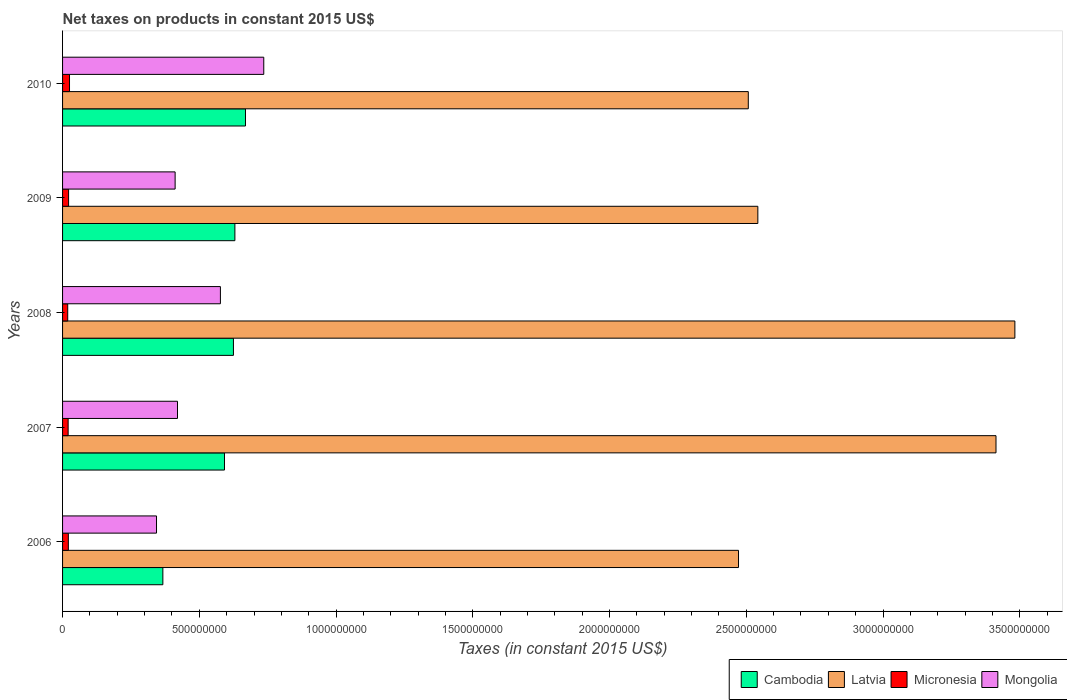How many groups of bars are there?
Make the answer very short. 5. Are the number of bars per tick equal to the number of legend labels?
Give a very brief answer. Yes. Are the number of bars on each tick of the Y-axis equal?
Keep it short and to the point. Yes. How many bars are there on the 1st tick from the top?
Your answer should be compact. 4. How many bars are there on the 4th tick from the bottom?
Ensure brevity in your answer.  4. What is the net taxes on products in Cambodia in 2008?
Offer a terse response. 6.25e+08. Across all years, what is the maximum net taxes on products in Latvia?
Provide a short and direct response. 3.48e+09. Across all years, what is the minimum net taxes on products in Mongolia?
Provide a short and direct response. 3.44e+08. In which year was the net taxes on products in Latvia maximum?
Provide a short and direct response. 2008. In which year was the net taxes on products in Mongolia minimum?
Provide a succinct answer. 2006. What is the total net taxes on products in Mongolia in the graph?
Offer a very short reply. 2.49e+09. What is the difference between the net taxes on products in Latvia in 2006 and that in 2007?
Your response must be concise. -9.41e+08. What is the difference between the net taxes on products in Latvia in 2010 and the net taxes on products in Mongolia in 2008?
Your answer should be very brief. 1.93e+09. What is the average net taxes on products in Mongolia per year?
Your answer should be compact. 4.98e+08. In the year 2007, what is the difference between the net taxes on products in Mongolia and net taxes on products in Latvia?
Your answer should be compact. -2.99e+09. In how many years, is the net taxes on products in Latvia greater than 400000000 US$?
Keep it short and to the point. 5. What is the ratio of the net taxes on products in Cambodia in 2006 to that in 2007?
Make the answer very short. 0.62. Is the net taxes on products in Latvia in 2006 less than that in 2009?
Ensure brevity in your answer.  Yes. What is the difference between the highest and the second highest net taxes on products in Latvia?
Give a very brief answer. 6.90e+07. What is the difference between the highest and the lowest net taxes on products in Mongolia?
Provide a short and direct response. 3.92e+08. In how many years, is the net taxes on products in Latvia greater than the average net taxes on products in Latvia taken over all years?
Give a very brief answer. 2. Is it the case that in every year, the sum of the net taxes on products in Mongolia and net taxes on products in Latvia is greater than the sum of net taxes on products in Micronesia and net taxes on products in Cambodia?
Give a very brief answer. No. What does the 3rd bar from the top in 2009 represents?
Your answer should be compact. Latvia. What does the 1st bar from the bottom in 2006 represents?
Give a very brief answer. Cambodia. Is it the case that in every year, the sum of the net taxes on products in Latvia and net taxes on products in Cambodia is greater than the net taxes on products in Micronesia?
Ensure brevity in your answer.  Yes. Are all the bars in the graph horizontal?
Your answer should be compact. Yes. How many years are there in the graph?
Make the answer very short. 5. What is the difference between two consecutive major ticks on the X-axis?
Keep it short and to the point. 5.00e+08. Are the values on the major ticks of X-axis written in scientific E-notation?
Ensure brevity in your answer.  No. Does the graph contain any zero values?
Your answer should be very brief. No. How many legend labels are there?
Offer a very short reply. 4. What is the title of the graph?
Provide a short and direct response. Net taxes on products in constant 2015 US$. What is the label or title of the X-axis?
Your response must be concise. Taxes (in constant 2015 US$). What is the label or title of the Y-axis?
Your response must be concise. Years. What is the Taxes (in constant 2015 US$) of Cambodia in 2006?
Provide a succinct answer. 3.67e+08. What is the Taxes (in constant 2015 US$) in Latvia in 2006?
Provide a succinct answer. 2.47e+09. What is the Taxes (in constant 2015 US$) in Micronesia in 2006?
Ensure brevity in your answer.  2.11e+07. What is the Taxes (in constant 2015 US$) of Mongolia in 2006?
Your response must be concise. 3.44e+08. What is the Taxes (in constant 2015 US$) in Cambodia in 2007?
Provide a short and direct response. 5.92e+08. What is the Taxes (in constant 2015 US$) of Latvia in 2007?
Provide a short and direct response. 3.41e+09. What is the Taxes (in constant 2015 US$) in Micronesia in 2007?
Keep it short and to the point. 2.04e+07. What is the Taxes (in constant 2015 US$) in Mongolia in 2007?
Ensure brevity in your answer.  4.20e+08. What is the Taxes (in constant 2015 US$) in Cambodia in 2008?
Your response must be concise. 6.25e+08. What is the Taxes (in constant 2015 US$) in Latvia in 2008?
Your response must be concise. 3.48e+09. What is the Taxes (in constant 2015 US$) in Micronesia in 2008?
Your response must be concise. 1.88e+07. What is the Taxes (in constant 2015 US$) in Mongolia in 2008?
Give a very brief answer. 5.77e+08. What is the Taxes (in constant 2015 US$) in Cambodia in 2009?
Provide a succinct answer. 6.30e+08. What is the Taxes (in constant 2015 US$) in Latvia in 2009?
Your answer should be very brief. 2.54e+09. What is the Taxes (in constant 2015 US$) of Micronesia in 2009?
Give a very brief answer. 2.20e+07. What is the Taxes (in constant 2015 US$) of Mongolia in 2009?
Your answer should be compact. 4.12e+08. What is the Taxes (in constant 2015 US$) in Cambodia in 2010?
Your response must be concise. 6.69e+08. What is the Taxes (in constant 2015 US$) in Latvia in 2010?
Keep it short and to the point. 2.51e+09. What is the Taxes (in constant 2015 US$) in Micronesia in 2010?
Your answer should be compact. 2.54e+07. What is the Taxes (in constant 2015 US$) in Mongolia in 2010?
Make the answer very short. 7.36e+08. Across all years, what is the maximum Taxes (in constant 2015 US$) of Cambodia?
Your answer should be very brief. 6.69e+08. Across all years, what is the maximum Taxes (in constant 2015 US$) in Latvia?
Provide a short and direct response. 3.48e+09. Across all years, what is the maximum Taxes (in constant 2015 US$) of Micronesia?
Your answer should be very brief. 2.54e+07. Across all years, what is the maximum Taxes (in constant 2015 US$) in Mongolia?
Keep it short and to the point. 7.36e+08. Across all years, what is the minimum Taxes (in constant 2015 US$) of Cambodia?
Keep it short and to the point. 3.67e+08. Across all years, what is the minimum Taxes (in constant 2015 US$) in Latvia?
Your answer should be very brief. 2.47e+09. Across all years, what is the minimum Taxes (in constant 2015 US$) of Micronesia?
Offer a terse response. 1.88e+07. Across all years, what is the minimum Taxes (in constant 2015 US$) of Mongolia?
Provide a succinct answer. 3.44e+08. What is the total Taxes (in constant 2015 US$) of Cambodia in the graph?
Offer a very short reply. 2.88e+09. What is the total Taxes (in constant 2015 US$) of Latvia in the graph?
Your answer should be very brief. 1.44e+1. What is the total Taxes (in constant 2015 US$) in Micronesia in the graph?
Give a very brief answer. 1.08e+08. What is the total Taxes (in constant 2015 US$) of Mongolia in the graph?
Ensure brevity in your answer.  2.49e+09. What is the difference between the Taxes (in constant 2015 US$) in Cambodia in 2006 and that in 2007?
Your response must be concise. -2.25e+08. What is the difference between the Taxes (in constant 2015 US$) in Latvia in 2006 and that in 2007?
Your response must be concise. -9.41e+08. What is the difference between the Taxes (in constant 2015 US$) in Micronesia in 2006 and that in 2007?
Your answer should be very brief. 6.88e+05. What is the difference between the Taxes (in constant 2015 US$) of Mongolia in 2006 and that in 2007?
Your response must be concise. -7.67e+07. What is the difference between the Taxes (in constant 2015 US$) of Cambodia in 2006 and that in 2008?
Your answer should be very brief. -2.58e+08. What is the difference between the Taxes (in constant 2015 US$) of Latvia in 2006 and that in 2008?
Provide a succinct answer. -1.01e+09. What is the difference between the Taxes (in constant 2015 US$) of Micronesia in 2006 and that in 2008?
Your response must be concise. 2.27e+06. What is the difference between the Taxes (in constant 2015 US$) of Mongolia in 2006 and that in 2008?
Offer a very short reply. -2.34e+08. What is the difference between the Taxes (in constant 2015 US$) of Cambodia in 2006 and that in 2009?
Make the answer very short. -2.63e+08. What is the difference between the Taxes (in constant 2015 US$) of Latvia in 2006 and that in 2009?
Your response must be concise. -7.07e+07. What is the difference between the Taxes (in constant 2015 US$) of Micronesia in 2006 and that in 2009?
Your answer should be very brief. -9.20e+05. What is the difference between the Taxes (in constant 2015 US$) of Mongolia in 2006 and that in 2009?
Your response must be concise. -6.81e+07. What is the difference between the Taxes (in constant 2015 US$) of Cambodia in 2006 and that in 2010?
Your answer should be compact. -3.02e+08. What is the difference between the Taxes (in constant 2015 US$) of Latvia in 2006 and that in 2010?
Your answer should be compact. -3.58e+07. What is the difference between the Taxes (in constant 2015 US$) in Micronesia in 2006 and that in 2010?
Make the answer very short. -4.33e+06. What is the difference between the Taxes (in constant 2015 US$) of Mongolia in 2006 and that in 2010?
Offer a very short reply. -3.92e+08. What is the difference between the Taxes (in constant 2015 US$) of Cambodia in 2007 and that in 2008?
Keep it short and to the point. -3.27e+07. What is the difference between the Taxes (in constant 2015 US$) in Latvia in 2007 and that in 2008?
Provide a succinct answer. -6.90e+07. What is the difference between the Taxes (in constant 2015 US$) of Micronesia in 2007 and that in 2008?
Provide a succinct answer. 1.59e+06. What is the difference between the Taxes (in constant 2015 US$) in Mongolia in 2007 and that in 2008?
Provide a short and direct response. -1.57e+08. What is the difference between the Taxes (in constant 2015 US$) of Cambodia in 2007 and that in 2009?
Provide a short and direct response. -3.81e+07. What is the difference between the Taxes (in constant 2015 US$) in Latvia in 2007 and that in 2009?
Offer a terse response. 8.71e+08. What is the difference between the Taxes (in constant 2015 US$) in Micronesia in 2007 and that in 2009?
Offer a very short reply. -1.61e+06. What is the difference between the Taxes (in constant 2015 US$) in Mongolia in 2007 and that in 2009?
Offer a very short reply. 8.67e+06. What is the difference between the Taxes (in constant 2015 US$) in Cambodia in 2007 and that in 2010?
Ensure brevity in your answer.  -7.68e+07. What is the difference between the Taxes (in constant 2015 US$) of Latvia in 2007 and that in 2010?
Your answer should be compact. 9.06e+08. What is the difference between the Taxes (in constant 2015 US$) of Micronesia in 2007 and that in 2010?
Your answer should be very brief. -5.02e+06. What is the difference between the Taxes (in constant 2015 US$) in Mongolia in 2007 and that in 2010?
Your answer should be compact. -3.15e+08. What is the difference between the Taxes (in constant 2015 US$) of Cambodia in 2008 and that in 2009?
Offer a terse response. -5.33e+06. What is the difference between the Taxes (in constant 2015 US$) of Latvia in 2008 and that in 2009?
Keep it short and to the point. 9.40e+08. What is the difference between the Taxes (in constant 2015 US$) in Micronesia in 2008 and that in 2009?
Give a very brief answer. -3.19e+06. What is the difference between the Taxes (in constant 2015 US$) of Mongolia in 2008 and that in 2009?
Make the answer very short. 1.66e+08. What is the difference between the Taxes (in constant 2015 US$) of Cambodia in 2008 and that in 2010?
Keep it short and to the point. -4.40e+07. What is the difference between the Taxes (in constant 2015 US$) in Latvia in 2008 and that in 2010?
Make the answer very short. 9.75e+08. What is the difference between the Taxes (in constant 2015 US$) of Micronesia in 2008 and that in 2010?
Keep it short and to the point. -6.60e+06. What is the difference between the Taxes (in constant 2015 US$) in Mongolia in 2008 and that in 2010?
Your response must be concise. -1.59e+08. What is the difference between the Taxes (in constant 2015 US$) in Cambodia in 2009 and that in 2010?
Make the answer very short. -3.87e+07. What is the difference between the Taxes (in constant 2015 US$) of Latvia in 2009 and that in 2010?
Give a very brief answer. 3.49e+07. What is the difference between the Taxes (in constant 2015 US$) in Micronesia in 2009 and that in 2010?
Ensure brevity in your answer.  -3.41e+06. What is the difference between the Taxes (in constant 2015 US$) in Mongolia in 2009 and that in 2010?
Offer a terse response. -3.24e+08. What is the difference between the Taxes (in constant 2015 US$) of Cambodia in 2006 and the Taxes (in constant 2015 US$) of Latvia in 2007?
Offer a terse response. -3.05e+09. What is the difference between the Taxes (in constant 2015 US$) of Cambodia in 2006 and the Taxes (in constant 2015 US$) of Micronesia in 2007?
Offer a terse response. 3.46e+08. What is the difference between the Taxes (in constant 2015 US$) in Cambodia in 2006 and the Taxes (in constant 2015 US$) in Mongolia in 2007?
Make the answer very short. -5.35e+07. What is the difference between the Taxes (in constant 2015 US$) in Latvia in 2006 and the Taxes (in constant 2015 US$) in Micronesia in 2007?
Provide a succinct answer. 2.45e+09. What is the difference between the Taxes (in constant 2015 US$) in Latvia in 2006 and the Taxes (in constant 2015 US$) in Mongolia in 2007?
Ensure brevity in your answer.  2.05e+09. What is the difference between the Taxes (in constant 2015 US$) in Micronesia in 2006 and the Taxes (in constant 2015 US$) in Mongolia in 2007?
Your answer should be compact. -3.99e+08. What is the difference between the Taxes (in constant 2015 US$) of Cambodia in 2006 and the Taxes (in constant 2015 US$) of Latvia in 2008?
Make the answer very short. -3.12e+09. What is the difference between the Taxes (in constant 2015 US$) of Cambodia in 2006 and the Taxes (in constant 2015 US$) of Micronesia in 2008?
Your answer should be very brief. 3.48e+08. What is the difference between the Taxes (in constant 2015 US$) in Cambodia in 2006 and the Taxes (in constant 2015 US$) in Mongolia in 2008?
Provide a short and direct response. -2.10e+08. What is the difference between the Taxes (in constant 2015 US$) of Latvia in 2006 and the Taxes (in constant 2015 US$) of Micronesia in 2008?
Your answer should be compact. 2.45e+09. What is the difference between the Taxes (in constant 2015 US$) in Latvia in 2006 and the Taxes (in constant 2015 US$) in Mongolia in 2008?
Your answer should be compact. 1.89e+09. What is the difference between the Taxes (in constant 2015 US$) in Micronesia in 2006 and the Taxes (in constant 2015 US$) in Mongolia in 2008?
Ensure brevity in your answer.  -5.56e+08. What is the difference between the Taxes (in constant 2015 US$) of Cambodia in 2006 and the Taxes (in constant 2015 US$) of Latvia in 2009?
Your answer should be compact. -2.18e+09. What is the difference between the Taxes (in constant 2015 US$) of Cambodia in 2006 and the Taxes (in constant 2015 US$) of Micronesia in 2009?
Ensure brevity in your answer.  3.45e+08. What is the difference between the Taxes (in constant 2015 US$) in Cambodia in 2006 and the Taxes (in constant 2015 US$) in Mongolia in 2009?
Keep it short and to the point. -4.49e+07. What is the difference between the Taxes (in constant 2015 US$) in Latvia in 2006 and the Taxes (in constant 2015 US$) in Micronesia in 2009?
Provide a short and direct response. 2.45e+09. What is the difference between the Taxes (in constant 2015 US$) in Latvia in 2006 and the Taxes (in constant 2015 US$) in Mongolia in 2009?
Keep it short and to the point. 2.06e+09. What is the difference between the Taxes (in constant 2015 US$) of Micronesia in 2006 and the Taxes (in constant 2015 US$) of Mongolia in 2009?
Make the answer very short. -3.90e+08. What is the difference between the Taxes (in constant 2015 US$) in Cambodia in 2006 and the Taxes (in constant 2015 US$) in Latvia in 2010?
Your answer should be compact. -2.14e+09. What is the difference between the Taxes (in constant 2015 US$) in Cambodia in 2006 and the Taxes (in constant 2015 US$) in Micronesia in 2010?
Offer a terse response. 3.41e+08. What is the difference between the Taxes (in constant 2015 US$) in Cambodia in 2006 and the Taxes (in constant 2015 US$) in Mongolia in 2010?
Offer a very short reply. -3.69e+08. What is the difference between the Taxes (in constant 2015 US$) of Latvia in 2006 and the Taxes (in constant 2015 US$) of Micronesia in 2010?
Ensure brevity in your answer.  2.45e+09. What is the difference between the Taxes (in constant 2015 US$) of Latvia in 2006 and the Taxes (in constant 2015 US$) of Mongolia in 2010?
Provide a succinct answer. 1.74e+09. What is the difference between the Taxes (in constant 2015 US$) in Micronesia in 2006 and the Taxes (in constant 2015 US$) in Mongolia in 2010?
Keep it short and to the point. -7.15e+08. What is the difference between the Taxes (in constant 2015 US$) of Cambodia in 2007 and the Taxes (in constant 2015 US$) of Latvia in 2008?
Provide a short and direct response. -2.89e+09. What is the difference between the Taxes (in constant 2015 US$) in Cambodia in 2007 and the Taxes (in constant 2015 US$) in Micronesia in 2008?
Your response must be concise. 5.73e+08. What is the difference between the Taxes (in constant 2015 US$) in Cambodia in 2007 and the Taxes (in constant 2015 US$) in Mongolia in 2008?
Offer a very short reply. 1.49e+07. What is the difference between the Taxes (in constant 2015 US$) in Latvia in 2007 and the Taxes (in constant 2015 US$) in Micronesia in 2008?
Make the answer very short. 3.39e+09. What is the difference between the Taxes (in constant 2015 US$) in Latvia in 2007 and the Taxes (in constant 2015 US$) in Mongolia in 2008?
Offer a terse response. 2.84e+09. What is the difference between the Taxes (in constant 2015 US$) of Micronesia in 2007 and the Taxes (in constant 2015 US$) of Mongolia in 2008?
Offer a terse response. -5.57e+08. What is the difference between the Taxes (in constant 2015 US$) of Cambodia in 2007 and the Taxes (in constant 2015 US$) of Latvia in 2009?
Your answer should be very brief. -1.95e+09. What is the difference between the Taxes (in constant 2015 US$) in Cambodia in 2007 and the Taxes (in constant 2015 US$) in Micronesia in 2009?
Give a very brief answer. 5.70e+08. What is the difference between the Taxes (in constant 2015 US$) in Cambodia in 2007 and the Taxes (in constant 2015 US$) in Mongolia in 2009?
Provide a succinct answer. 1.80e+08. What is the difference between the Taxes (in constant 2015 US$) of Latvia in 2007 and the Taxes (in constant 2015 US$) of Micronesia in 2009?
Offer a very short reply. 3.39e+09. What is the difference between the Taxes (in constant 2015 US$) in Latvia in 2007 and the Taxes (in constant 2015 US$) in Mongolia in 2009?
Ensure brevity in your answer.  3.00e+09. What is the difference between the Taxes (in constant 2015 US$) of Micronesia in 2007 and the Taxes (in constant 2015 US$) of Mongolia in 2009?
Offer a terse response. -3.91e+08. What is the difference between the Taxes (in constant 2015 US$) in Cambodia in 2007 and the Taxes (in constant 2015 US$) in Latvia in 2010?
Your answer should be very brief. -1.92e+09. What is the difference between the Taxes (in constant 2015 US$) of Cambodia in 2007 and the Taxes (in constant 2015 US$) of Micronesia in 2010?
Ensure brevity in your answer.  5.67e+08. What is the difference between the Taxes (in constant 2015 US$) of Cambodia in 2007 and the Taxes (in constant 2015 US$) of Mongolia in 2010?
Offer a terse response. -1.44e+08. What is the difference between the Taxes (in constant 2015 US$) in Latvia in 2007 and the Taxes (in constant 2015 US$) in Micronesia in 2010?
Provide a short and direct response. 3.39e+09. What is the difference between the Taxes (in constant 2015 US$) in Latvia in 2007 and the Taxes (in constant 2015 US$) in Mongolia in 2010?
Keep it short and to the point. 2.68e+09. What is the difference between the Taxes (in constant 2015 US$) of Micronesia in 2007 and the Taxes (in constant 2015 US$) of Mongolia in 2010?
Provide a short and direct response. -7.15e+08. What is the difference between the Taxes (in constant 2015 US$) in Cambodia in 2008 and the Taxes (in constant 2015 US$) in Latvia in 2009?
Give a very brief answer. -1.92e+09. What is the difference between the Taxes (in constant 2015 US$) of Cambodia in 2008 and the Taxes (in constant 2015 US$) of Micronesia in 2009?
Provide a succinct answer. 6.03e+08. What is the difference between the Taxes (in constant 2015 US$) of Cambodia in 2008 and the Taxes (in constant 2015 US$) of Mongolia in 2009?
Your response must be concise. 2.13e+08. What is the difference between the Taxes (in constant 2015 US$) of Latvia in 2008 and the Taxes (in constant 2015 US$) of Micronesia in 2009?
Offer a terse response. 3.46e+09. What is the difference between the Taxes (in constant 2015 US$) of Latvia in 2008 and the Taxes (in constant 2015 US$) of Mongolia in 2009?
Ensure brevity in your answer.  3.07e+09. What is the difference between the Taxes (in constant 2015 US$) in Micronesia in 2008 and the Taxes (in constant 2015 US$) in Mongolia in 2009?
Give a very brief answer. -3.93e+08. What is the difference between the Taxes (in constant 2015 US$) in Cambodia in 2008 and the Taxes (in constant 2015 US$) in Latvia in 2010?
Your answer should be compact. -1.88e+09. What is the difference between the Taxes (in constant 2015 US$) of Cambodia in 2008 and the Taxes (in constant 2015 US$) of Micronesia in 2010?
Offer a terse response. 5.99e+08. What is the difference between the Taxes (in constant 2015 US$) in Cambodia in 2008 and the Taxes (in constant 2015 US$) in Mongolia in 2010?
Offer a terse response. -1.11e+08. What is the difference between the Taxes (in constant 2015 US$) of Latvia in 2008 and the Taxes (in constant 2015 US$) of Micronesia in 2010?
Offer a terse response. 3.46e+09. What is the difference between the Taxes (in constant 2015 US$) of Latvia in 2008 and the Taxes (in constant 2015 US$) of Mongolia in 2010?
Your response must be concise. 2.75e+09. What is the difference between the Taxes (in constant 2015 US$) of Micronesia in 2008 and the Taxes (in constant 2015 US$) of Mongolia in 2010?
Provide a succinct answer. -7.17e+08. What is the difference between the Taxes (in constant 2015 US$) of Cambodia in 2009 and the Taxes (in constant 2015 US$) of Latvia in 2010?
Provide a succinct answer. -1.88e+09. What is the difference between the Taxes (in constant 2015 US$) in Cambodia in 2009 and the Taxes (in constant 2015 US$) in Micronesia in 2010?
Provide a succinct answer. 6.05e+08. What is the difference between the Taxes (in constant 2015 US$) in Cambodia in 2009 and the Taxes (in constant 2015 US$) in Mongolia in 2010?
Your answer should be very brief. -1.06e+08. What is the difference between the Taxes (in constant 2015 US$) in Latvia in 2009 and the Taxes (in constant 2015 US$) in Micronesia in 2010?
Your answer should be compact. 2.52e+09. What is the difference between the Taxes (in constant 2015 US$) of Latvia in 2009 and the Taxes (in constant 2015 US$) of Mongolia in 2010?
Offer a very short reply. 1.81e+09. What is the difference between the Taxes (in constant 2015 US$) of Micronesia in 2009 and the Taxes (in constant 2015 US$) of Mongolia in 2010?
Give a very brief answer. -7.14e+08. What is the average Taxes (in constant 2015 US$) in Cambodia per year?
Your answer should be very brief. 5.77e+08. What is the average Taxes (in constant 2015 US$) of Latvia per year?
Make the answer very short. 2.88e+09. What is the average Taxes (in constant 2015 US$) of Micronesia per year?
Give a very brief answer. 2.16e+07. What is the average Taxes (in constant 2015 US$) in Mongolia per year?
Give a very brief answer. 4.98e+08. In the year 2006, what is the difference between the Taxes (in constant 2015 US$) of Cambodia and Taxes (in constant 2015 US$) of Latvia?
Provide a short and direct response. -2.10e+09. In the year 2006, what is the difference between the Taxes (in constant 2015 US$) of Cambodia and Taxes (in constant 2015 US$) of Micronesia?
Make the answer very short. 3.46e+08. In the year 2006, what is the difference between the Taxes (in constant 2015 US$) of Cambodia and Taxes (in constant 2015 US$) of Mongolia?
Your answer should be very brief. 2.32e+07. In the year 2006, what is the difference between the Taxes (in constant 2015 US$) in Latvia and Taxes (in constant 2015 US$) in Micronesia?
Provide a short and direct response. 2.45e+09. In the year 2006, what is the difference between the Taxes (in constant 2015 US$) of Latvia and Taxes (in constant 2015 US$) of Mongolia?
Your response must be concise. 2.13e+09. In the year 2006, what is the difference between the Taxes (in constant 2015 US$) in Micronesia and Taxes (in constant 2015 US$) in Mongolia?
Offer a terse response. -3.22e+08. In the year 2007, what is the difference between the Taxes (in constant 2015 US$) of Cambodia and Taxes (in constant 2015 US$) of Latvia?
Make the answer very short. -2.82e+09. In the year 2007, what is the difference between the Taxes (in constant 2015 US$) of Cambodia and Taxes (in constant 2015 US$) of Micronesia?
Ensure brevity in your answer.  5.72e+08. In the year 2007, what is the difference between the Taxes (in constant 2015 US$) in Cambodia and Taxes (in constant 2015 US$) in Mongolia?
Give a very brief answer. 1.72e+08. In the year 2007, what is the difference between the Taxes (in constant 2015 US$) in Latvia and Taxes (in constant 2015 US$) in Micronesia?
Your response must be concise. 3.39e+09. In the year 2007, what is the difference between the Taxes (in constant 2015 US$) of Latvia and Taxes (in constant 2015 US$) of Mongolia?
Give a very brief answer. 2.99e+09. In the year 2007, what is the difference between the Taxes (in constant 2015 US$) of Micronesia and Taxes (in constant 2015 US$) of Mongolia?
Provide a succinct answer. -4.00e+08. In the year 2008, what is the difference between the Taxes (in constant 2015 US$) in Cambodia and Taxes (in constant 2015 US$) in Latvia?
Provide a short and direct response. -2.86e+09. In the year 2008, what is the difference between the Taxes (in constant 2015 US$) of Cambodia and Taxes (in constant 2015 US$) of Micronesia?
Provide a short and direct response. 6.06e+08. In the year 2008, what is the difference between the Taxes (in constant 2015 US$) in Cambodia and Taxes (in constant 2015 US$) in Mongolia?
Your answer should be very brief. 4.77e+07. In the year 2008, what is the difference between the Taxes (in constant 2015 US$) of Latvia and Taxes (in constant 2015 US$) of Micronesia?
Your answer should be compact. 3.46e+09. In the year 2008, what is the difference between the Taxes (in constant 2015 US$) in Latvia and Taxes (in constant 2015 US$) in Mongolia?
Your answer should be compact. 2.91e+09. In the year 2008, what is the difference between the Taxes (in constant 2015 US$) of Micronesia and Taxes (in constant 2015 US$) of Mongolia?
Your answer should be very brief. -5.58e+08. In the year 2009, what is the difference between the Taxes (in constant 2015 US$) of Cambodia and Taxes (in constant 2015 US$) of Latvia?
Ensure brevity in your answer.  -1.91e+09. In the year 2009, what is the difference between the Taxes (in constant 2015 US$) in Cambodia and Taxes (in constant 2015 US$) in Micronesia?
Keep it short and to the point. 6.08e+08. In the year 2009, what is the difference between the Taxes (in constant 2015 US$) in Cambodia and Taxes (in constant 2015 US$) in Mongolia?
Keep it short and to the point. 2.19e+08. In the year 2009, what is the difference between the Taxes (in constant 2015 US$) of Latvia and Taxes (in constant 2015 US$) of Micronesia?
Provide a short and direct response. 2.52e+09. In the year 2009, what is the difference between the Taxes (in constant 2015 US$) of Latvia and Taxes (in constant 2015 US$) of Mongolia?
Make the answer very short. 2.13e+09. In the year 2009, what is the difference between the Taxes (in constant 2015 US$) in Micronesia and Taxes (in constant 2015 US$) in Mongolia?
Give a very brief answer. -3.90e+08. In the year 2010, what is the difference between the Taxes (in constant 2015 US$) of Cambodia and Taxes (in constant 2015 US$) of Latvia?
Offer a very short reply. -1.84e+09. In the year 2010, what is the difference between the Taxes (in constant 2015 US$) in Cambodia and Taxes (in constant 2015 US$) in Micronesia?
Keep it short and to the point. 6.43e+08. In the year 2010, what is the difference between the Taxes (in constant 2015 US$) of Cambodia and Taxes (in constant 2015 US$) of Mongolia?
Keep it short and to the point. -6.68e+07. In the year 2010, what is the difference between the Taxes (in constant 2015 US$) of Latvia and Taxes (in constant 2015 US$) of Micronesia?
Your answer should be compact. 2.48e+09. In the year 2010, what is the difference between the Taxes (in constant 2015 US$) in Latvia and Taxes (in constant 2015 US$) in Mongolia?
Your answer should be very brief. 1.77e+09. In the year 2010, what is the difference between the Taxes (in constant 2015 US$) of Micronesia and Taxes (in constant 2015 US$) of Mongolia?
Provide a short and direct response. -7.10e+08. What is the ratio of the Taxes (in constant 2015 US$) of Cambodia in 2006 to that in 2007?
Your response must be concise. 0.62. What is the ratio of the Taxes (in constant 2015 US$) of Latvia in 2006 to that in 2007?
Ensure brevity in your answer.  0.72. What is the ratio of the Taxes (in constant 2015 US$) of Micronesia in 2006 to that in 2007?
Keep it short and to the point. 1.03. What is the ratio of the Taxes (in constant 2015 US$) of Mongolia in 2006 to that in 2007?
Your answer should be very brief. 0.82. What is the ratio of the Taxes (in constant 2015 US$) in Cambodia in 2006 to that in 2008?
Keep it short and to the point. 0.59. What is the ratio of the Taxes (in constant 2015 US$) of Latvia in 2006 to that in 2008?
Ensure brevity in your answer.  0.71. What is the ratio of the Taxes (in constant 2015 US$) of Micronesia in 2006 to that in 2008?
Give a very brief answer. 1.12. What is the ratio of the Taxes (in constant 2015 US$) in Mongolia in 2006 to that in 2008?
Give a very brief answer. 0.6. What is the ratio of the Taxes (in constant 2015 US$) in Cambodia in 2006 to that in 2009?
Your response must be concise. 0.58. What is the ratio of the Taxes (in constant 2015 US$) in Latvia in 2006 to that in 2009?
Offer a very short reply. 0.97. What is the ratio of the Taxes (in constant 2015 US$) of Micronesia in 2006 to that in 2009?
Make the answer very short. 0.96. What is the ratio of the Taxes (in constant 2015 US$) in Mongolia in 2006 to that in 2009?
Offer a very short reply. 0.83. What is the ratio of the Taxes (in constant 2015 US$) in Cambodia in 2006 to that in 2010?
Provide a succinct answer. 0.55. What is the ratio of the Taxes (in constant 2015 US$) of Latvia in 2006 to that in 2010?
Keep it short and to the point. 0.99. What is the ratio of the Taxes (in constant 2015 US$) in Micronesia in 2006 to that in 2010?
Keep it short and to the point. 0.83. What is the ratio of the Taxes (in constant 2015 US$) in Mongolia in 2006 to that in 2010?
Ensure brevity in your answer.  0.47. What is the ratio of the Taxes (in constant 2015 US$) of Cambodia in 2007 to that in 2008?
Provide a succinct answer. 0.95. What is the ratio of the Taxes (in constant 2015 US$) of Latvia in 2007 to that in 2008?
Offer a terse response. 0.98. What is the ratio of the Taxes (in constant 2015 US$) in Micronesia in 2007 to that in 2008?
Offer a terse response. 1.08. What is the ratio of the Taxes (in constant 2015 US$) in Mongolia in 2007 to that in 2008?
Your answer should be very brief. 0.73. What is the ratio of the Taxes (in constant 2015 US$) of Cambodia in 2007 to that in 2009?
Ensure brevity in your answer.  0.94. What is the ratio of the Taxes (in constant 2015 US$) in Latvia in 2007 to that in 2009?
Your answer should be compact. 1.34. What is the ratio of the Taxes (in constant 2015 US$) in Micronesia in 2007 to that in 2009?
Give a very brief answer. 0.93. What is the ratio of the Taxes (in constant 2015 US$) of Mongolia in 2007 to that in 2009?
Offer a very short reply. 1.02. What is the ratio of the Taxes (in constant 2015 US$) of Cambodia in 2007 to that in 2010?
Offer a very short reply. 0.89. What is the ratio of the Taxes (in constant 2015 US$) in Latvia in 2007 to that in 2010?
Provide a short and direct response. 1.36. What is the ratio of the Taxes (in constant 2015 US$) of Micronesia in 2007 to that in 2010?
Your response must be concise. 0.8. What is the ratio of the Taxes (in constant 2015 US$) in Mongolia in 2007 to that in 2010?
Your answer should be very brief. 0.57. What is the ratio of the Taxes (in constant 2015 US$) of Cambodia in 2008 to that in 2009?
Your answer should be compact. 0.99. What is the ratio of the Taxes (in constant 2015 US$) in Latvia in 2008 to that in 2009?
Ensure brevity in your answer.  1.37. What is the ratio of the Taxes (in constant 2015 US$) in Micronesia in 2008 to that in 2009?
Your answer should be compact. 0.85. What is the ratio of the Taxes (in constant 2015 US$) of Mongolia in 2008 to that in 2009?
Keep it short and to the point. 1.4. What is the ratio of the Taxes (in constant 2015 US$) in Cambodia in 2008 to that in 2010?
Provide a short and direct response. 0.93. What is the ratio of the Taxes (in constant 2015 US$) in Latvia in 2008 to that in 2010?
Your answer should be compact. 1.39. What is the ratio of the Taxes (in constant 2015 US$) in Micronesia in 2008 to that in 2010?
Give a very brief answer. 0.74. What is the ratio of the Taxes (in constant 2015 US$) of Mongolia in 2008 to that in 2010?
Your answer should be very brief. 0.78. What is the ratio of the Taxes (in constant 2015 US$) in Cambodia in 2009 to that in 2010?
Your answer should be very brief. 0.94. What is the ratio of the Taxes (in constant 2015 US$) in Latvia in 2009 to that in 2010?
Provide a short and direct response. 1.01. What is the ratio of the Taxes (in constant 2015 US$) of Micronesia in 2009 to that in 2010?
Offer a terse response. 0.87. What is the ratio of the Taxes (in constant 2015 US$) of Mongolia in 2009 to that in 2010?
Keep it short and to the point. 0.56. What is the difference between the highest and the second highest Taxes (in constant 2015 US$) of Cambodia?
Your response must be concise. 3.87e+07. What is the difference between the highest and the second highest Taxes (in constant 2015 US$) of Latvia?
Make the answer very short. 6.90e+07. What is the difference between the highest and the second highest Taxes (in constant 2015 US$) of Micronesia?
Ensure brevity in your answer.  3.41e+06. What is the difference between the highest and the second highest Taxes (in constant 2015 US$) in Mongolia?
Your answer should be compact. 1.59e+08. What is the difference between the highest and the lowest Taxes (in constant 2015 US$) of Cambodia?
Provide a short and direct response. 3.02e+08. What is the difference between the highest and the lowest Taxes (in constant 2015 US$) in Latvia?
Your response must be concise. 1.01e+09. What is the difference between the highest and the lowest Taxes (in constant 2015 US$) in Micronesia?
Your answer should be compact. 6.60e+06. What is the difference between the highest and the lowest Taxes (in constant 2015 US$) in Mongolia?
Make the answer very short. 3.92e+08. 